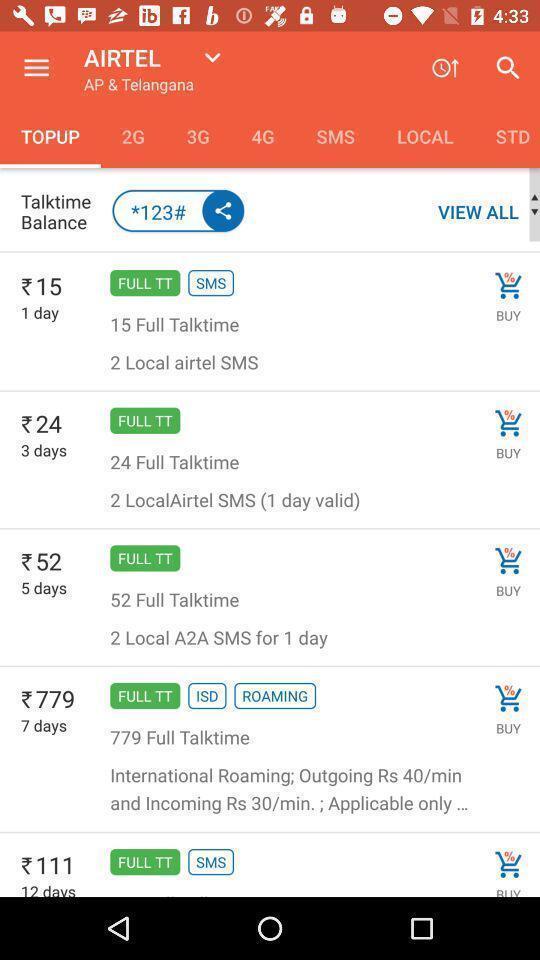Provide a detailed account of this screenshot. Screen shows multiple options in a recharge application. 